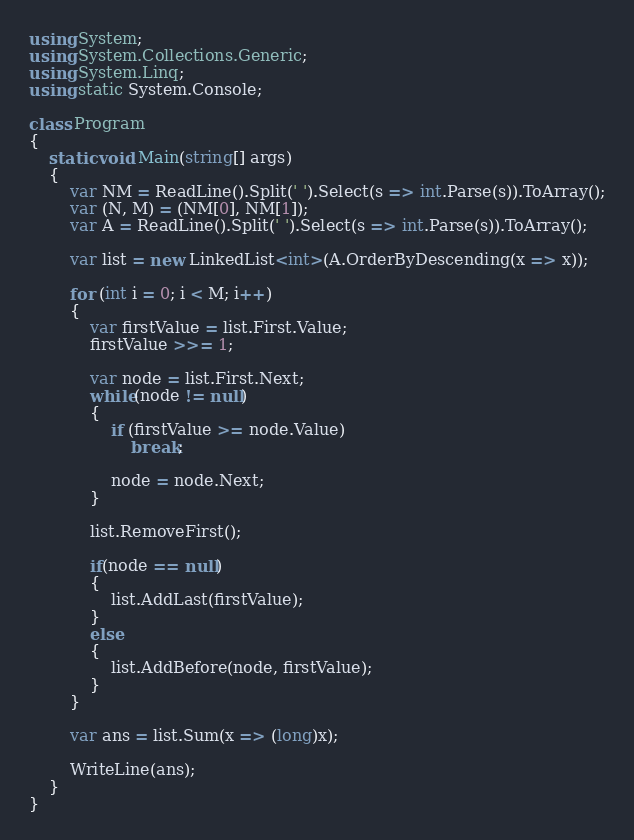Convert code to text. <code><loc_0><loc_0><loc_500><loc_500><_C#_>using System;
using System.Collections.Generic;
using System.Linq;
using static System.Console;

class Program
{
    static void Main(string[] args)
    {
        var NM = ReadLine().Split(' ').Select(s => int.Parse(s)).ToArray();
        var (N, M) = (NM[0], NM[1]);
        var A = ReadLine().Split(' ').Select(s => int.Parse(s)).ToArray();

        var list = new LinkedList<int>(A.OrderByDescending(x => x));

        for (int i = 0; i < M; i++)
        {
            var firstValue = list.First.Value;
            firstValue >>= 1;

            var node = list.First.Next;
            while(node != null)
            {
                if (firstValue >= node.Value)
                    break;

                node = node.Next;
            }

            list.RemoveFirst();

            if(node == null)
            {
                list.AddLast(firstValue);
            }
            else
            {
                list.AddBefore(node, firstValue);
            }
        }

        var ans = list.Sum(x => (long)x);

        WriteLine(ans);
    }
}
</code> 